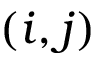Convert formula to latex. <formula><loc_0><loc_0><loc_500><loc_500>( i , j )</formula> 